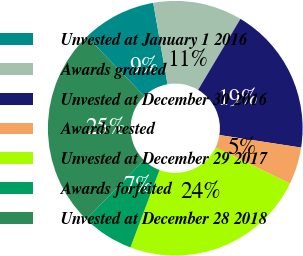<chart> <loc_0><loc_0><loc_500><loc_500><pie_chart><fcel>Unvested at January 1 2016<fcel>Awards granted<fcel>Unvested at December 30 2016<fcel>Awards vested<fcel>Unvested at December 29 2017<fcel>Awards forfeited<fcel>Unvested at December 28 2018<nl><fcel>9.43%<fcel>11.32%<fcel>18.87%<fcel>4.72%<fcel>23.58%<fcel>6.6%<fcel>25.47%<nl></chart> 